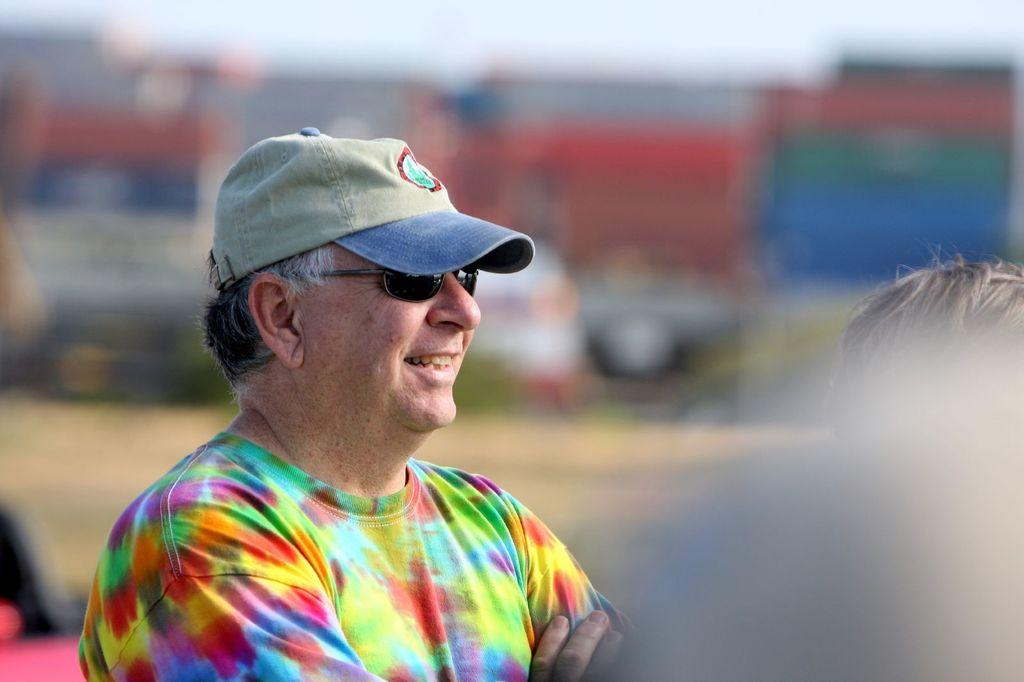Who is the main subject in the image? There is a man in the center of the image. What is the man wearing on his head? The man is wearing a hat. What else is the man wearing in the image? The man is also wearing goggles. Can you describe the background of the image? The background of the image is blurry. What type of surface is visible in the center of the image? There is ground visible in the center of the image. What type of insect can be seen crawling on the plate in the image? There is no plate or insect present in the image. What is the man's reaction to the loss he has experienced in the image? There is no indication of loss or any emotional reaction in the image. 